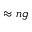<formula> <loc_0><loc_0><loc_500><loc_500>\approx n g</formula> 